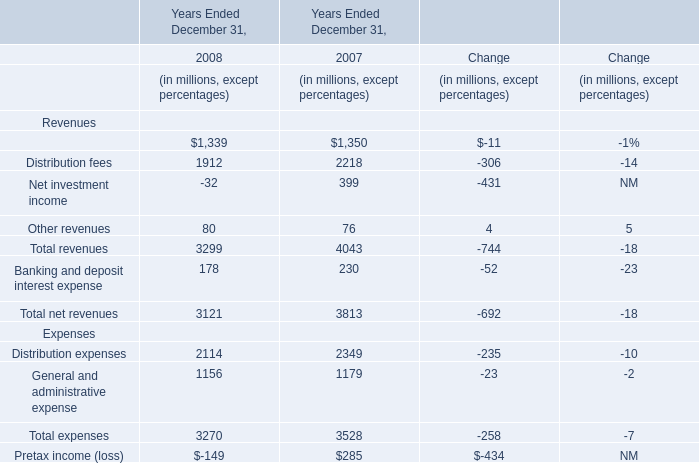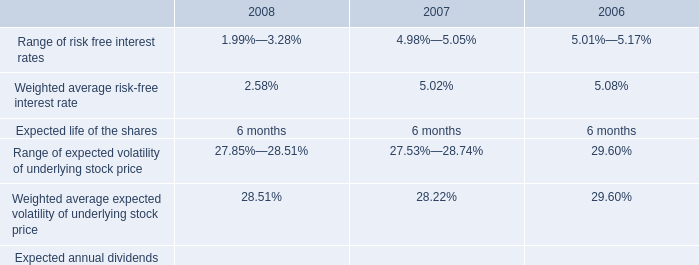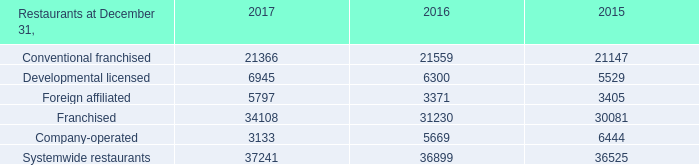what is the growth rate in the price of espp shares purchased from 2007 to 2008? 
Computations: ((7.89 - 9.09) / 9.09)
Answer: -0.13201. 